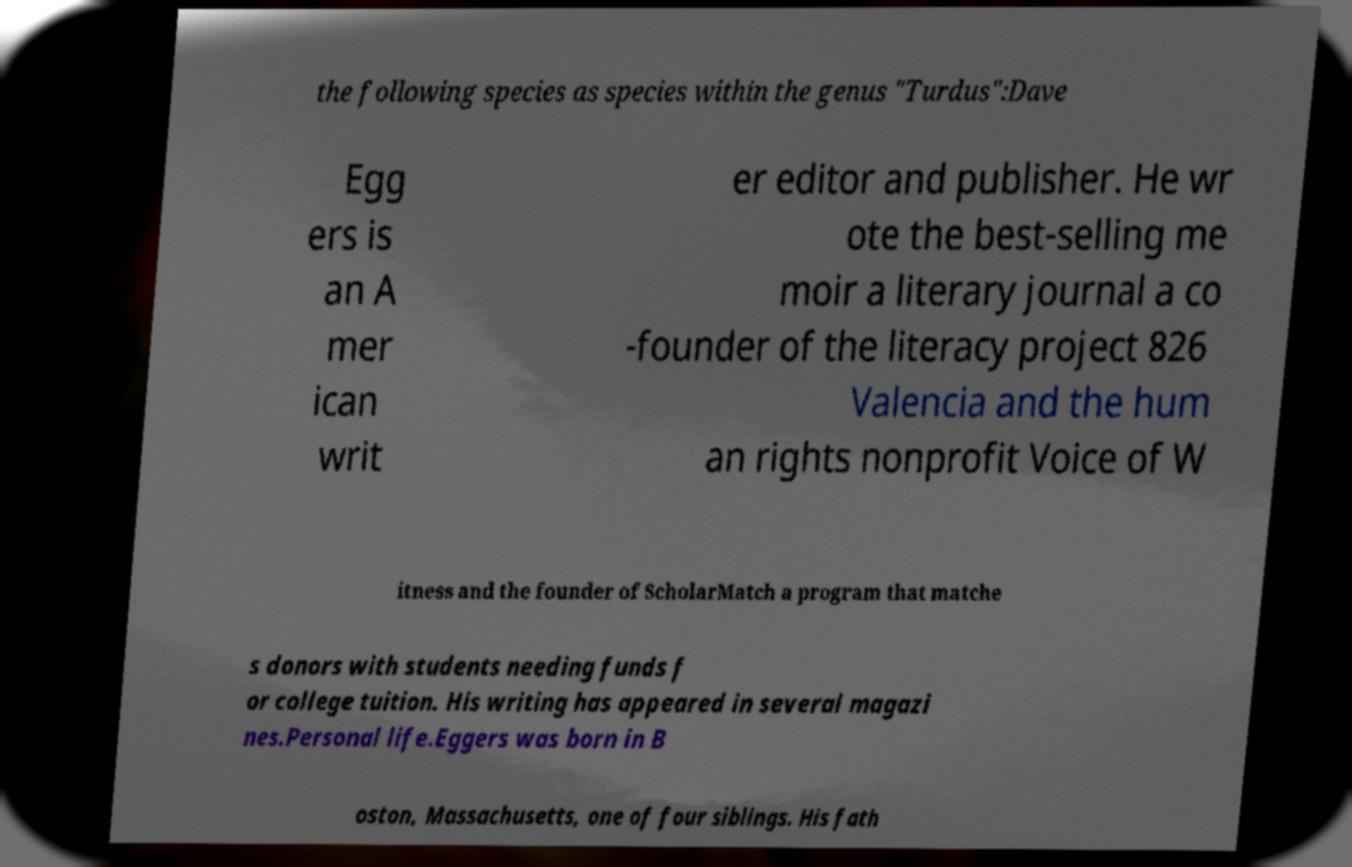Could you extract and type out the text from this image? the following species as species within the genus "Turdus":Dave Egg ers is an A mer ican writ er editor and publisher. He wr ote the best-selling me moir a literary journal a co -founder of the literacy project 826 Valencia and the hum an rights nonprofit Voice of W itness and the founder of ScholarMatch a program that matche s donors with students needing funds f or college tuition. His writing has appeared in several magazi nes.Personal life.Eggers was born in B oston, Massachusetts, one of four siblings. His fath 